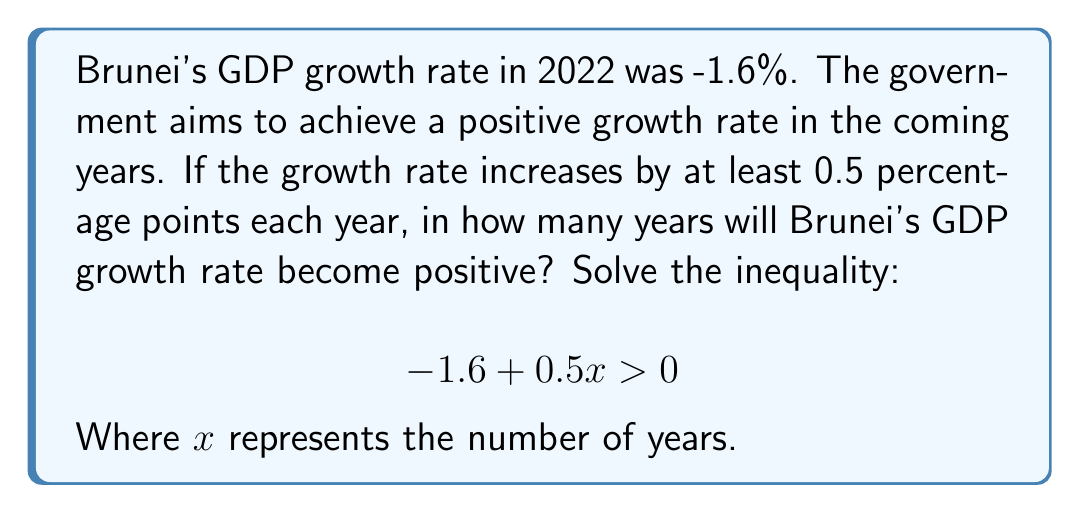What is the answer to this math problem? Let's solve this inequality step by step:

1) We start with the inequality:
   $$ -1.6 + 0.5x > 0 $$

2) Add 1.6 to both sides to isolate the term with x:
   $$ -1.6 + 0.5x + 1.6 > 0 + 1.6 $$
   $$ 0.5x > 1.6 $$

3) Divide both sides by 0.5:
   $$ \frac{0.5x}{0.5} > \frac{1.6}{0.5} $$
   $$ x > 3.2 $$

4) Since x represents the number of years, which must be a whole number, we need to round up to the next integer.

5) Therefore, x must be at least 4 for the inequality to be satisfied.

This means that it will take at least 4 years for Brunei's GDP growth rate to become positive if it increases by 0.5 percentage points each year.
Answer: 4 years 